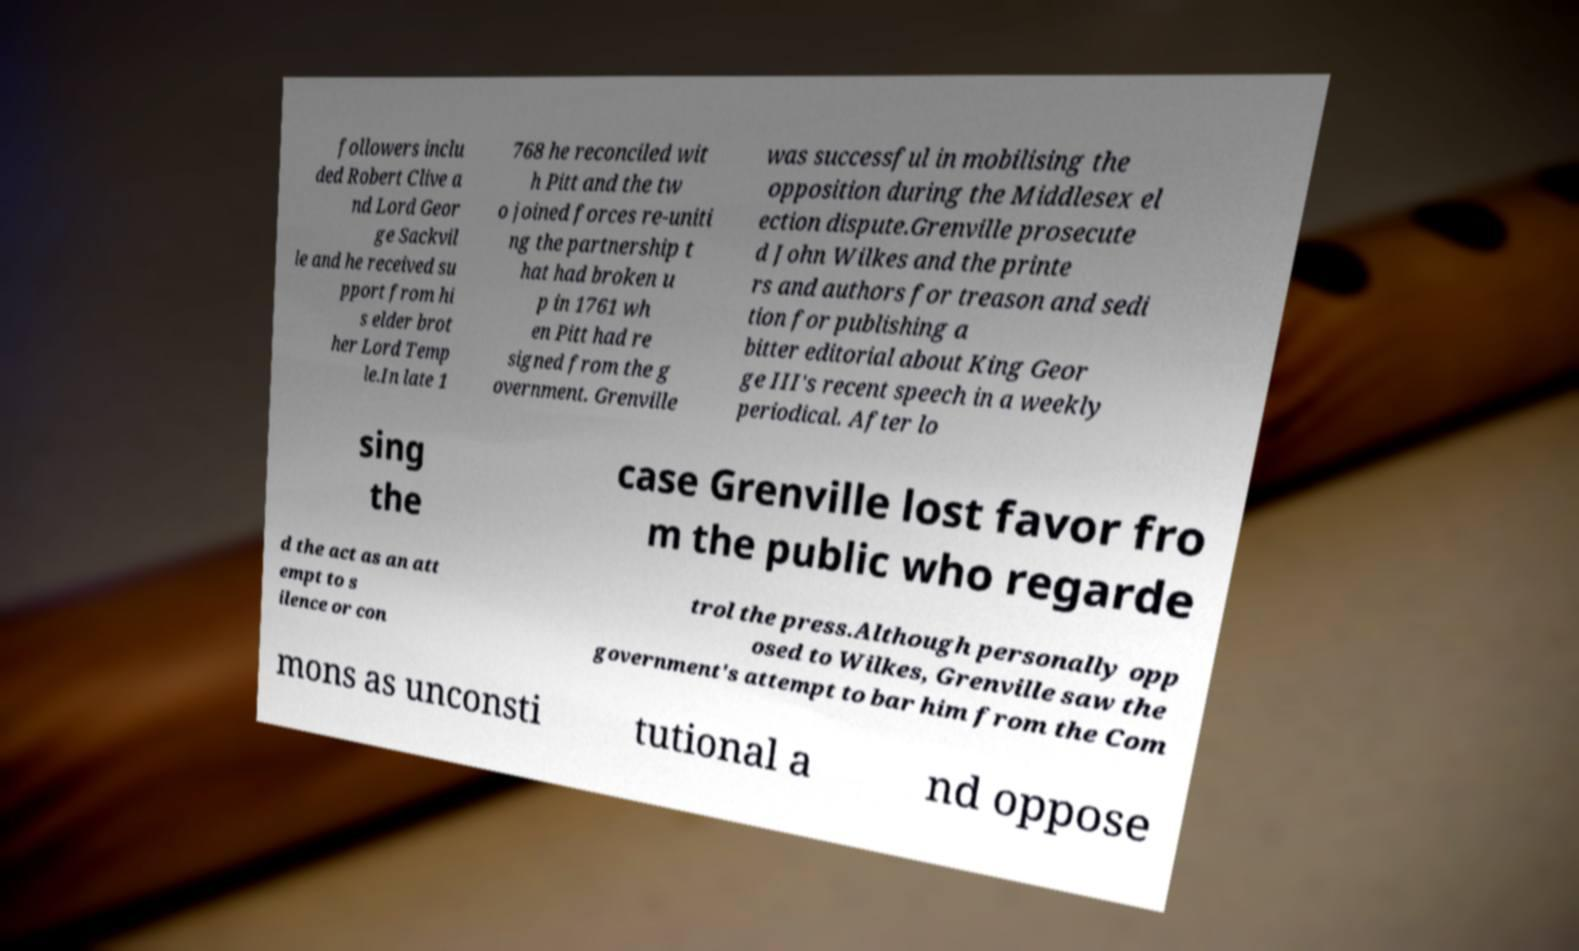Please identify and transcribe the text found in this image. followers inclu ded Robert Clive a nd Lord Geor ge Sackvil le and he received su pport from hi s elder brot her Lord Temp le.In late 1 768 he reconciled wit h Pitt and the tw o joined forces re-uniti ng the partnership t hat had broken u p in 1761 wh en Pitt had re signed from the g overnment. Grenville was successful in mobilising the opposition during the Middlesex el ection dispute.Grenville prosecute d John Wilkes and the printe rs and authors for treason and sedi tion for publishing a bitter editorial about King Geor ge III's recent speech in a weekly periodical. After lo sing the case Grenville lost favor fro m the public who regarde d the act as an att empt to s ilence or con trol the press.Although personally opp osed to Wilkes, Grenville saw the government's attempt to bar him from the Com mons as unconsti tutional a nd oppose 